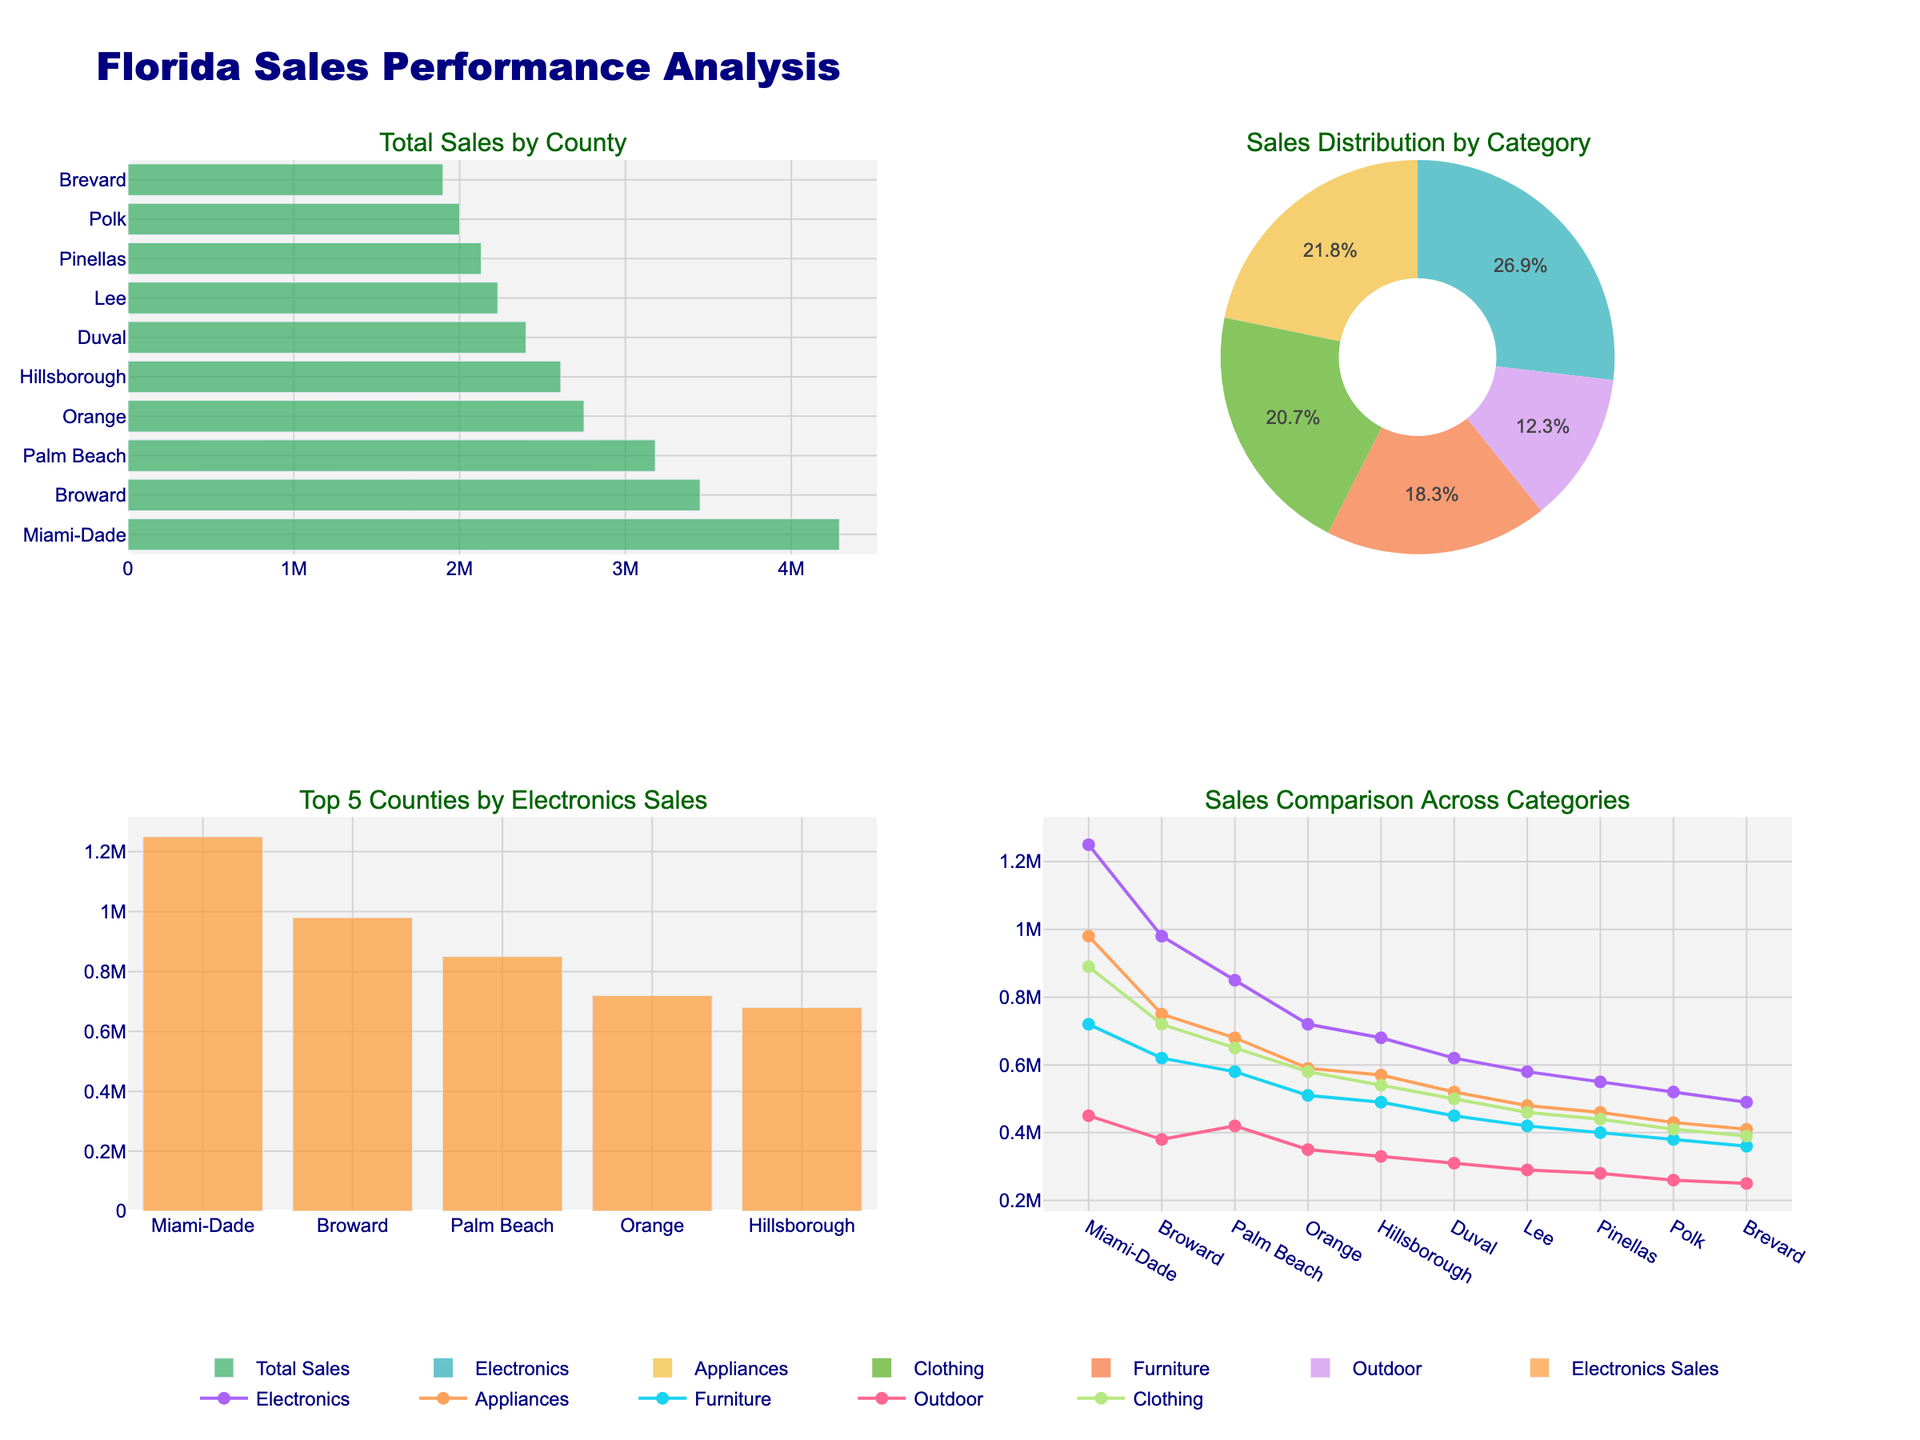What is the overall trend in the number of publications in the "Journal of Classical Studies" from 1920 to 2020? The overall trend shows an initial increase from 15 publications in 1920 to a peak of 32 in 2000, followed by a decline to 25 in 2020.
Answer: Increasing trend with a peak in 2000, then a decline Which journal had the highest number of publications in 1980? By visually inspecting the y-axis values for each subplot in the year 1980, the "Classical Quarterly" had the highest number of publications with 35.
Answer: Classical Quarterly How many publications were there in "Classical Antiquity" in 1940 compared to 2000? In 1940, the number of publications in "Classical Antiquity" was 0, and in 2000, it was 12. Therefore, publications increased by 12 from 1940 to 2000.
Answer: Increased by 12 What is the average number of publications for "American Journal of Philology" across all the years shown? Sum the number of publications (18, 20, 24, 28, 30, 25) and divide by the number of data points (6). (18 + 20 + 24 + 28 + 30 + 25) / 6 = 145 / 6 = 24.17
Answer: 24.17 Which journal experienced the most significant decline in publications from 2000 to 2020? Comparing the differences in publication numbers from 2000 to 2020 for each journal: "Journal of Classical Studies" (-7), "Classical Quarterly" (-6), "Harvard Studies in Classical Philology" (-4), "American Journal of Philology" (-5), "Classical Antiquity" (-2). The "Journal of Classical Studies" experienced the most significant decline.
Answer: Journal of Classical Studies What is the highest number of publications recorded in "Harvard Studies in Classical Philology", and in which year did it occur? By inspecting the y-axis values for "Harvard Studies in Classical Philology" across the years, the highest number of publications is 20 in the year 2000.
Answer: 20 in 2000 In which decade did the "Classical Quarterly" see the most significant growth in publications? Calculate the growth in publications for each decade: 1920-1940 (+3), 1940-1960 (+5), 1960-1980 (+5), 1980-2000 (+3), 2000-2020 (-6). The most significant growth occurred between 1940 and 1960, and 1960 and 1980, both with +5 publications.
Answer: 1940-1960 and 1960-1980 Which journal remains the most consistent in terms of the number of publications over the past century? "Classical Antiquity" appears to be the most consistent, showing relatively minimal fluctuations compared to other journals, with a range of publications between 0 and 12.
Answer: Classical Antiquity How many data points are there in total for all journals combined? Count the number of data points for each journal (6 per journal) and multiply by the number of journals (5). 6 * 5 = 30 data points.
Answer: 30 